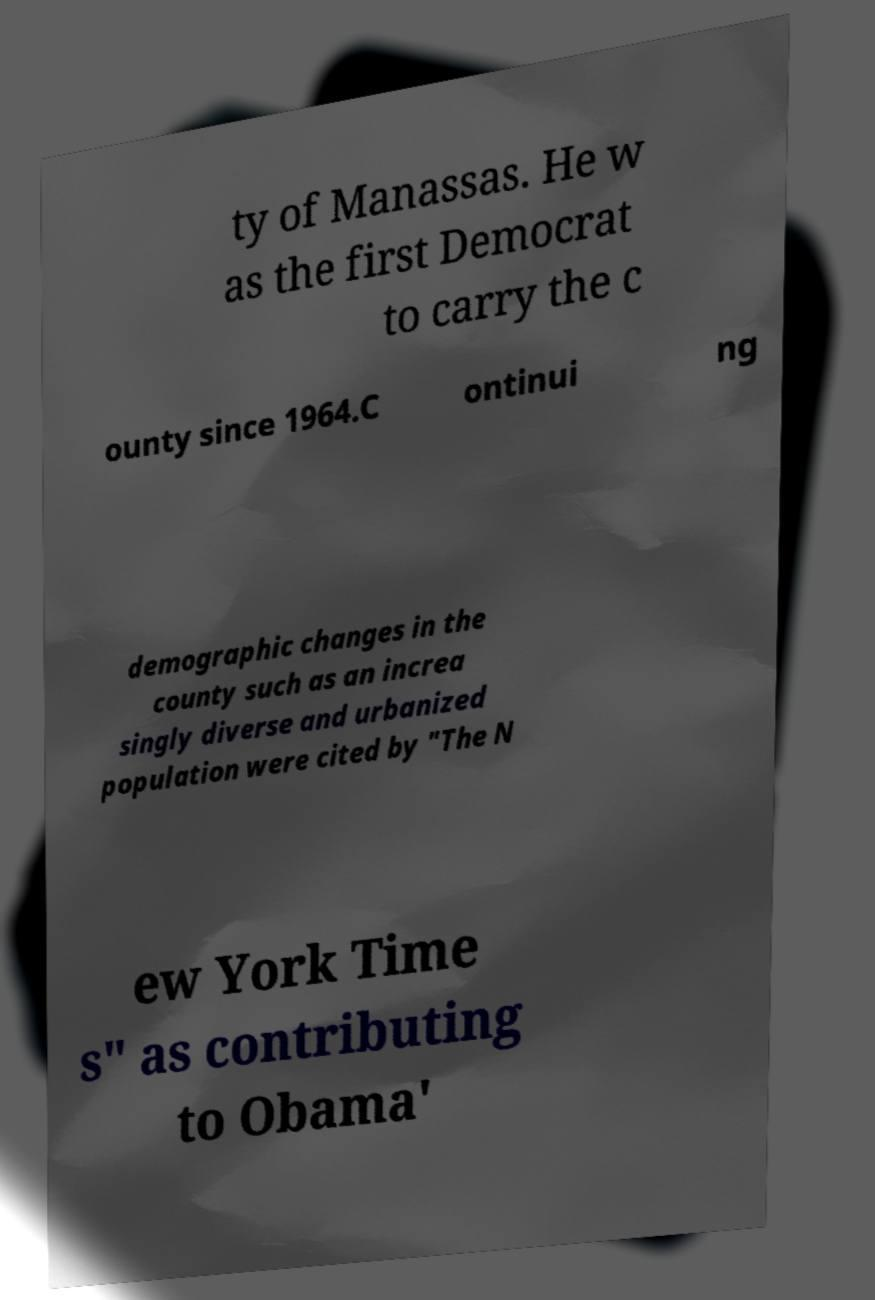Can you read and provide the text displayed in the image?This photo seems to have some interesting text. Can you extract and type it out for me? ty of Manassas. He w as the first Democrat to carry the c ounty since 1964.C ontinui ng demographic changes in the county such as an increa singly diverse and urbanized population were cited by "The N ew York Time s" as contributing to Obama' 